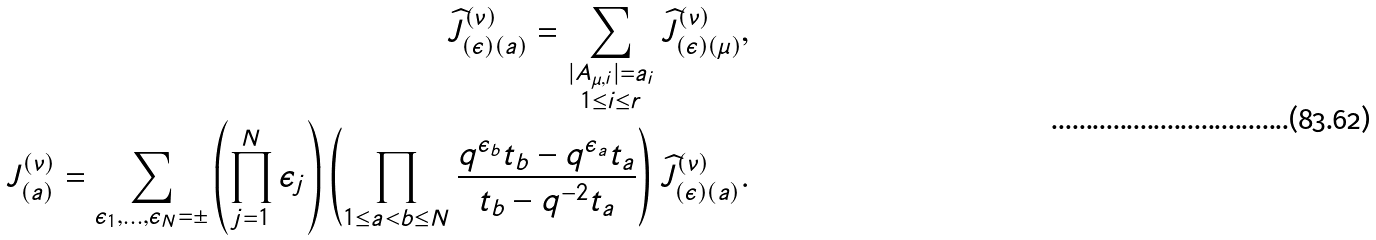<formula> <loc_0><loc_0><loc_500><loc_500>\widehat { J } _ { ( \epsilon ) ( a ) } ^ { ( \nu ) } = \sum _ { \substack { | A _ { \mu , i } | = a _ { i } \\ 1 \leq i \leq r } } \widehat { J } _ { ( \epsilon ) ( \mu ) } ^ { ( \nu ) } , \\ { J } _ { ( a ) } ^ { ( \nu ) } = \sum _ { \epsilon _ { 1 } , \dots , \epsilon _ { N } = \pm } \left ( \prod _ { j = 1 } ^ { N } \epsilon _ { j } \right ) \left ( \prod _ { 1 \leq a < b \leq N } \frac { q ^ { \epsilon _ { b } } t _ { b } - q ^ { \epsilon _ { a } } t _ { a } } { t _ { b } - q ^ { - 2 } t _ { a } } \right ) \widehat { J } _ { ( \epsilon ) ( a ) } ^ { ( \nu ) } .</formula> 